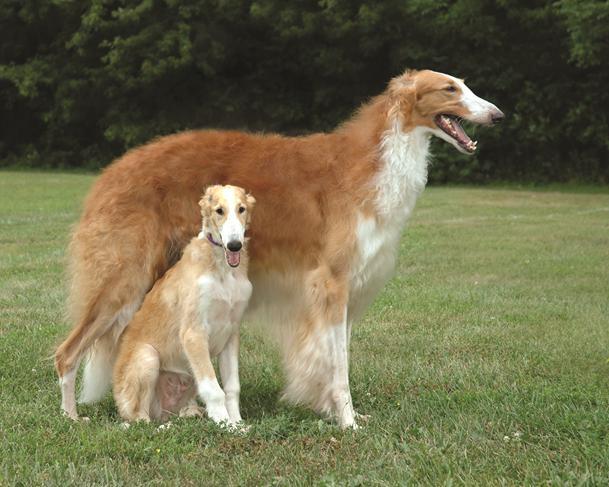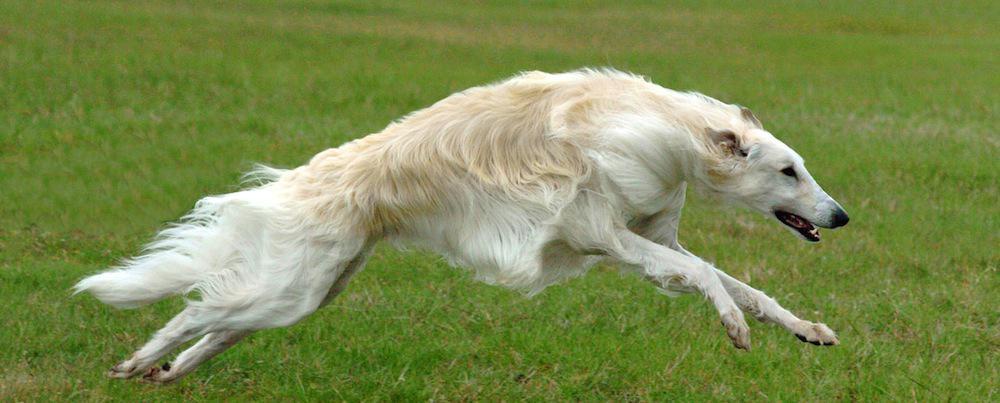The first image is the image on the left, the second image is the image on the right. For the images shown, is this caption "One of the images contains exactly two dogs." true? Answer yes or no. Yes. 